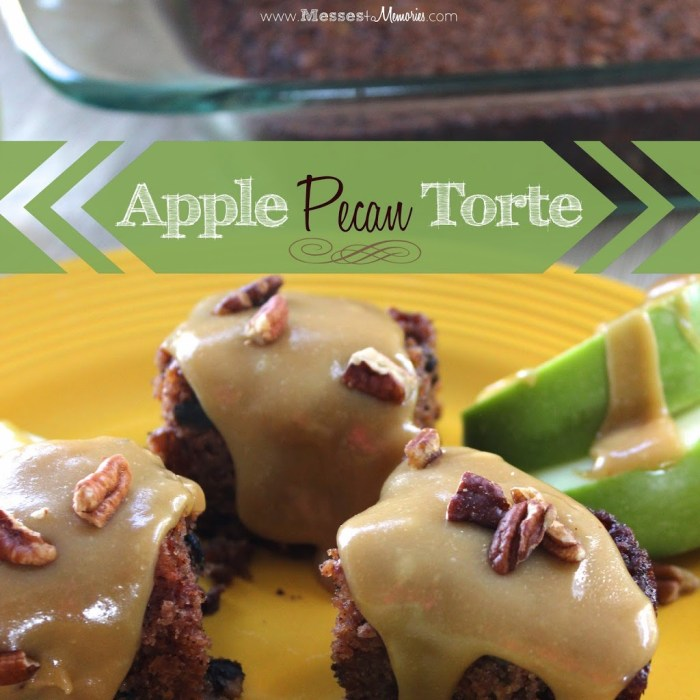Considering the elements presented in the image, what could be the main flavor profile of the dessert, and how do the garnish and topping choices complement the overall taste experience? The dessert depicted in the image likely marvels the taste buds with a primary flavor profile of apple and pecan, delightfully evident from its composition. The topping, a luscious caramel glaze, drapes over each piece with a sweet, decadent pool that enhances the crunchy pecans sprinkled atop. This topping not only deepens the dessert's richness but also marries well with the earthy, slightly bitter undertones of the pecans and the bright, sweet notes of the fresh apple slices that garnish it. Additionally, these apple slices introduce a crisp texture and a zest of freshness that cuts through the dessert's overall richness, providing a pleasing balance to each bite. Together, these elements craft a well-rounded flavor and sensory profile that is both indulgent and refreshing. 